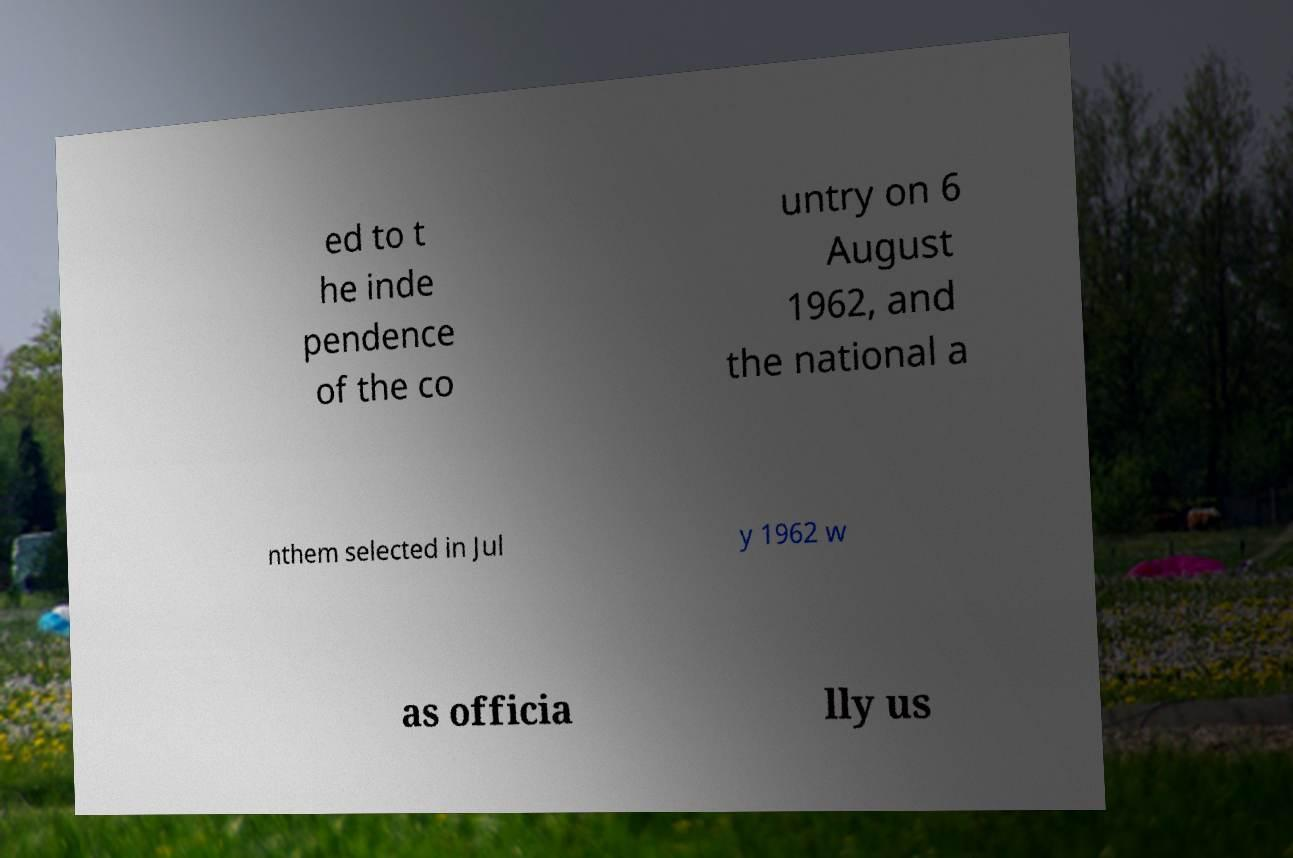For documentation purposes, I need the text within this image transcribed. Could you provide that? ed to t he inde pendence of the co untry on 6 August 1962, and the national a nthem selected in Jul y 1962 w as officia lly us 